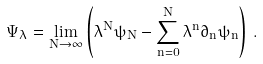Convert formula to latex. <formula><loc_0><loc_0><loc_500><loc_500>\Psi _ { \lambda } = \lim _ { N \rightarrow \infty } \left ( \lambda ^ { N } \psi _ { N } - \sum _ { n = 0 } ^ { N } \lambda ^ { n } \partial _ { n } \psi _ { n } \right ) \, .</formula> 